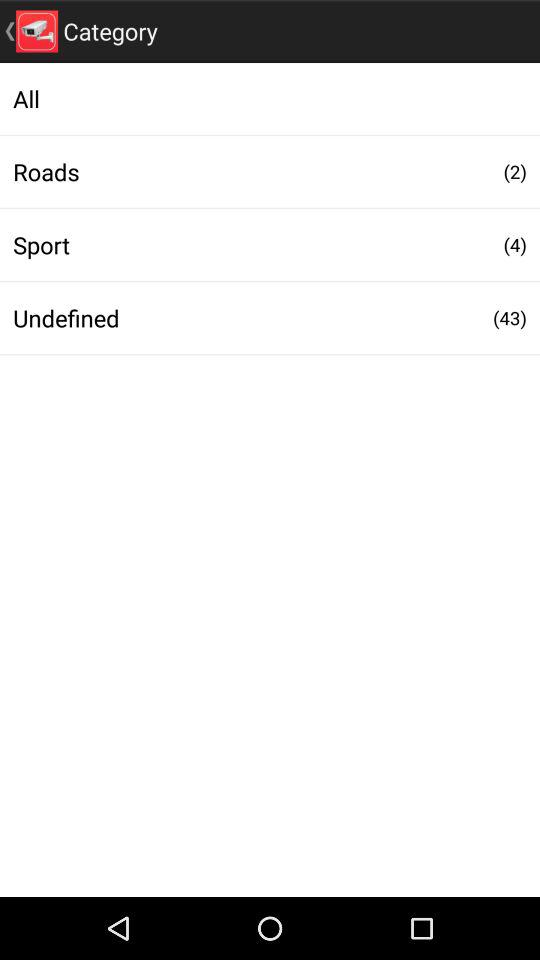How many roads are shown there? There are 2 roads. 